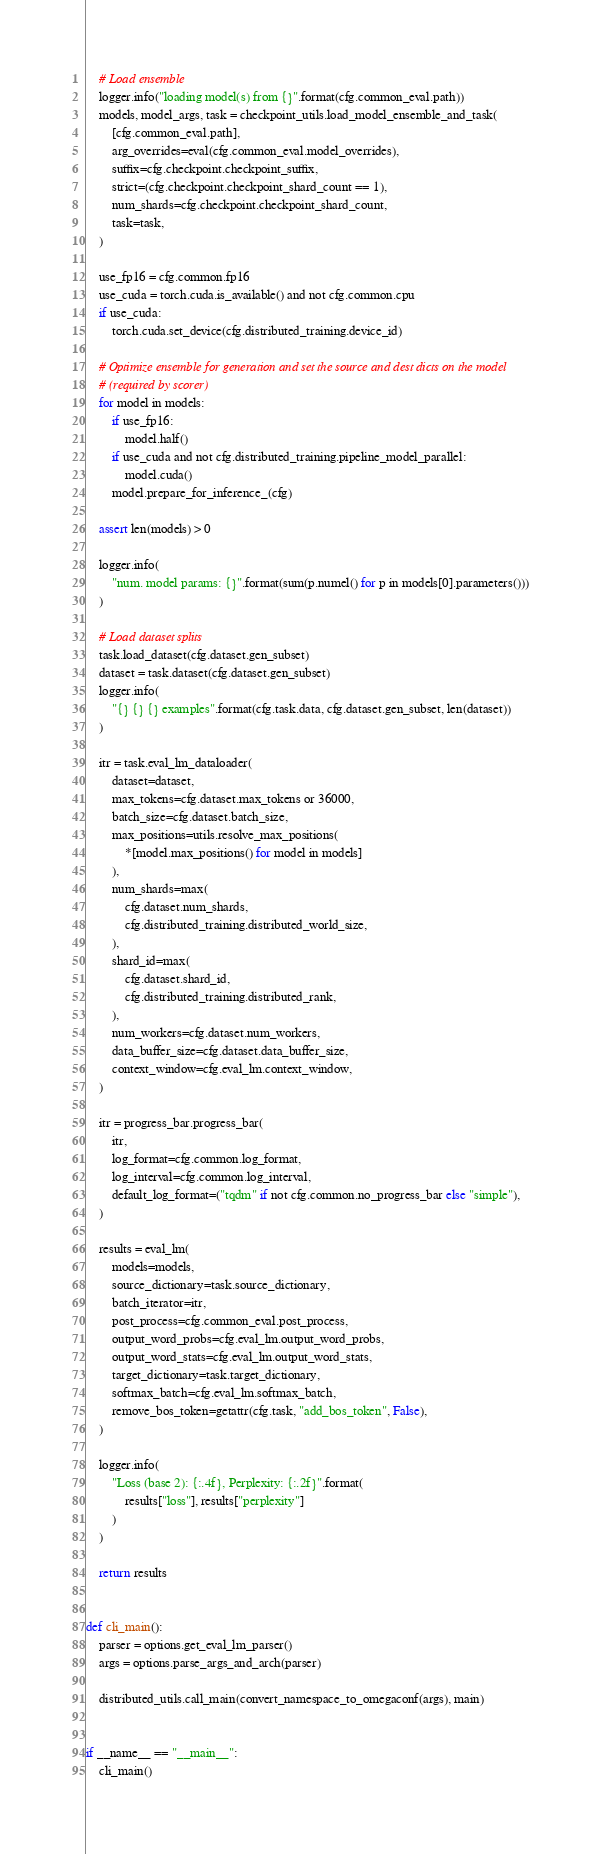<code> <loc_0><loc_0><loc_500><loc_500><_Python_>    # Load ensemble
    logger.info("loading model(s) from {}".format(cfg.common_eval.path))
    models, model_args, task = checkpoint_utils.load_model_ensemble_and_task(
        [cfg.common_eval.path],
        arg_overrides=eval(cfg.common_eval.model_overrides),
        suffix=cfg.checkpoint.checkpoint_suffix,
        strict=(cfg.checkpoint.checkpoint_shard_count == 1),
        num_shards=cfg.checkpoint.checkpoint_shard_count,
        task=task,
    )

    use_fp16 = cfg.common.fp16
    use_cuda = torch.cuda.is_available() and not cfg.common.cpu
    if use_cuda:
        torch.cuda.set_device(cfg.distributed_training.device_id)

    # Optimize ensemble for generation and set the source and dest dicts on the model
    # (required by scorer)
    for model in models:
        if use_fp16:
            model.half()
        if use_cuda and not cfg.distributed_training.pipeline_model_parallel:
            model.cuda()
        model.prepare_for_inference_(cfg)

    assert len(models) > 0

    logger.info(
        "num. model params: {}".format(sum(p.numel() for p in models[0].parameters()))
    )

    # Load dataset splits
    task.load_dataset(cfg.dataset.gen_subset)
    dataset = task.dataset(cfg.dataset.gen_subset)
    logger.info(
        "{} {} {} examples".format(cfg.task.data, cfg.dataset.gen_subset, len(dataset))
    )

    itr = task.eval_lm_dataloader(
        dataset=dataset,
        max_tokens=cfg.dataset.max_tokens or 36000,
        batch_size=cfg.dataset.batch_size,
        max_positions=utils.resolve_max_positions(
            *[model.max_positions() for model in models]
        ),
        num_shards=max(
            cfg.dataset.num_shards,
            cfg.distributed_training.distributed_world_size,
        ),
        shard_id=max(
            cfg.dataset.shard_id,
            cfg.distributed_training.distributed_rank,
        ),
        num_workers=cfg.dataset.num_workers,
        data_buffer_size=cfg.dataset.data_buffer_size,
        context_window=cfg.eval_lm.context_window,
    )

    itr = progress_bar.progress_bar(
        itr,
        log_format=cfg.common.log_format,
        log_interval=cfg.common.log_interval,
        default_log_format=("tqdm" if not cfg.common.no_progress_bar else "simple"),
    )

    results = eval_lm(
        models=models,
        source_dictionary=task.source_dictionary,
        batch_iterator=itr,
        post_process=cfg.common_eval.post_process,
        output_word_probs=cfg.eval_lm.output_word_probs,
        output_word_stats=cfg.eval_lm.output_word_stats,
        target_dictionary=task.target_dictionary,
        softmax_batch=cfg.eval_lm.softmax_batch,
        remove_bos_token=getattr(cfg.task, "add_bos_token", False),
    )

    logger.info(
        "Loss (base 2): {:.4f}, Perplexity: {:.2f}".format(
            results["loss"], results["perplexity"]
        )
    )

    return results


def cli_main():
    parser = options.get_eval_lm_parser()
    args = options.parse_args_and_arch(parser)

    distributed_utils.call_main(convert_namespace_to_omegaconf(args), main)


if __name__ == "__main__":
    cli_main()
</code> 